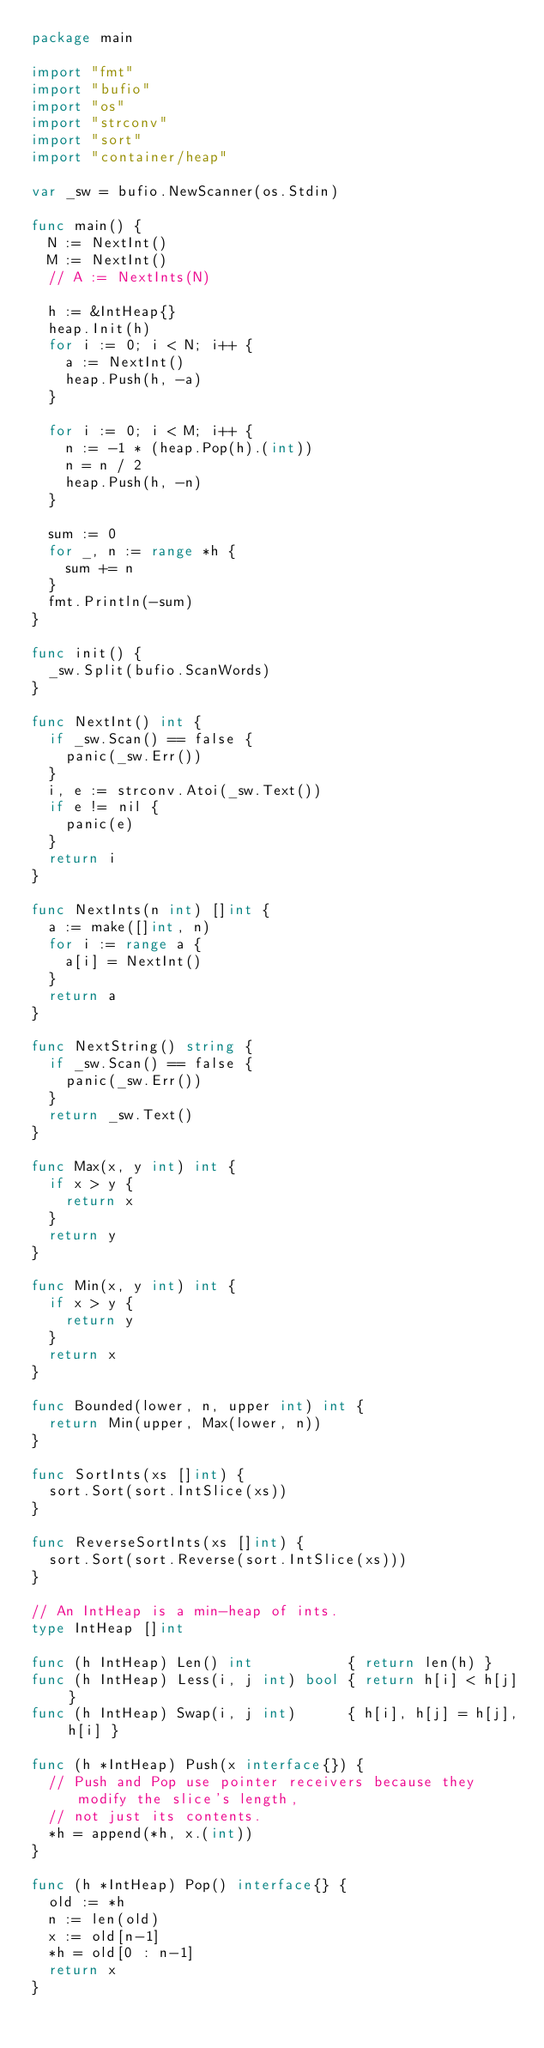Convert code to text. <code><loc_0><loc_0><loc_500><loc_500><_Go_>package main

import "fmt"
import "bufio"
import "os"
import "strconv"
import "sort"
import "container/heap"

var _sw = bufio.NewScanner(os.Stdin)

func main() {
	N := NextInt()
	M := NextInt()
	// A := NextInts(N)

	h := &IntHeap{}
	heap.Init(h)
	for i := 0; i < N; i++ {
		a := NextInt()
		heap.Push(h, -a)
	}

	for i := 0; i < M; i++ {
		n := -1 * (heap.Pop(h).(int))
		n = n / 2
		heap.Push(h, -n)
	}

	sum := 0
	for _, n := range *h {
		sum += n
	}
	fmt.Println(-sum)
}

func init() {
	_sw.Split(bufio.ScanWords)
}

func NextInt() int {
	if _sw.Scan() == false {
		panic(_sw.Err())
	}
	i, e := strconv.Atoi(_sw.Text())
	if e != nil {
		panic(e)
	}
	return i
}

func NextInts(n int) []int {
	a := make([]int, n)
	for i := range a {
		a[i] = NextInt()
	}
	return a
}

func NextString() string {
	if _sw.Scan() == false {
		panic(_sw.Err())
	}
	return _sw.Text()
}

func Max(x, y int) int {
	if x > y {
		return x
	}
	return y
}

func Min(x, y int) int {
	if x > y {
		return y
	}
	return x
}

func Bounded(lower, n, upper int) int {
	return Min(upper, Max(lower, n))
}

func SortInts(xs []int) {
	sort.Sort(sort.IntSlice(xs))
}

func ReverseSortInts(xs []int) {
	sort.Sort(sort.Reverse(sort.IntSlice(xs)))
}

// An IntHeap is a min-heap of ints.
type IntHeap []int

func (h IntHeap) Len() int           { return len(h) }
func (h IntHeap) Less(i, j int) bool { return h[i] < h[j] }
func (h IntHeap) Swap(i, j int)      { h[i], h[j] = h[j], h[i] }

func (h *IntHeap) Push(x interface{}) {
	// Push and Pop use pointer receivers because they modify the slice's length,
	// not just its contents.
	*h = append(*h, x.(int))
}

func (h *IntHeap) Pop() interface{} {
	old := *h
	n := len(old)
	x := old[n-1]
	*h = old[0 : n-1]
	return x
}
</code> 